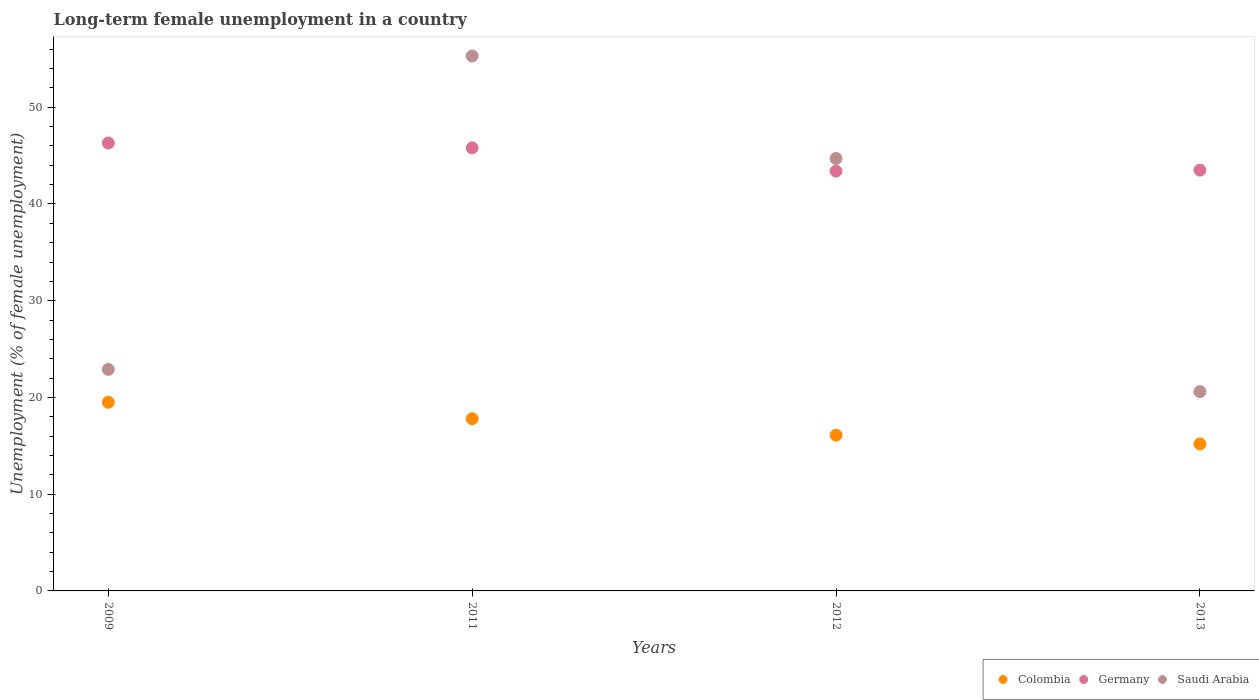How many different coloured dotlines are there?
Offer a very short reply. 3. What is the percentage of long-term unemployed female population in Colombia in 2009?
Offer a very short reply. 19.5. Across all years, what is the minimum percentage of long-term unemployed female population in Colombia?
Ensure brevity in your answer.  15.2. In which year was the percentage of long-term unemployed female population in Colombia minimum?
Provide a short and direct response. 2013. What is the total percentage of long-term unemployed female population in Colombia in the graph?
Give a very brief answer. 68.6. What is the difference between the percentage of long-term unemployed female population in Colombia in 2011 and that in 2013?
Your response must be concise. 2.6. What is the difference between the percentage of long-term unemployed female population in Germany in 2011 and the percentage of long-term unemployed female population in Saudi Arabia in 2013?
Your response must be concise. 25.2. What is the average percentage of long-term unemployed female population in Saudi Arabia per year?
Offer a very short reply. 35.88. In the year 2009, what is the difference between the percentage of long-term unemployed female population in Colombia and percentage of long-term unemployed female population in Germany?
Provide a succinct answer. -26.8. In how many years, is the percentage of long-term unemployed female population in Saudi Arabia greater than 40 %?
Provide a short and direct response. 2. What is the ratio of the percentage of long-term unemployed female population in Colombia in 2009 to that in 2013?
Ensure brevity in your answer.  1.28. Is the percentage of long-term unemployed female population in Germany in 2011 less than that in 2013?
Offer a very short reply. No. Is the difference between the percentage of long-term unemployed female population in Colombia in 2009 and 2012 greater than the difference between the percentage of long-term unemployed female population in Germany in 2009 and 2012?
Provide a short and direct response. Yes. What is the difference between the highest and the second highest percentage of long-term unemployed female population in Colombia?
Offer a terse response. 1.7. What is the difference between the highest and the lowest percentage of long-term unemployed female population in Colombia?
Keep it short and to the point. 4.3. Is the sum of the percentage of long-term unemployed female population in Germany in 2009 and 2011 greater than the maximum percentage of long-term unemployed female population in Saudi Arabia across all years?
Ensure brevity in your answer.  Yes. Are the values on the major ticks of Y-axis written in scientific E-notation?
Offer a terse response. No. Does the graph contain any zero values?
Make the answer very short. No. How many legend labels are there?
Your answer should be very brief. 3. What is the title of the graph?
Offer a terse response. Long-term female unemployment in a country. What is the label or title of the X-axis?
Your answer should be compact. Years. What is the label or title of the Y-axis?
Offer a very short reply. Unemployment (% of female unemployment). What is the Unemployment (% of female unemployment) of Colombia in 2009?
Make the answer very short. 19.5. What is the Unemployment (% of female unemployment) in Germany in 2009?
Your answer should be compact. 46.3. What is the Unemployment (% of female unemployment) of Saudi Arabia in 2009?
Provide a succinct answer. 22.9. What is the Unemployment (% of female unemployment) of Colombia in 2011?
Offer a very short reply. 17.8. What is the Unemployment (% of female unemployment) in Germany in 2011?
Your answer should be very brief. 45.8. What is the Unemployment (% of female unemployment) of Saudi Arabia in 2011?
Offer a terse response. 55.3. What is the Unemployment (% of female unemployment) of Colombia in 2012?
Offer a terse response. 16.1. What is the Unemployment (% of female unemployment) of Germany in 2012?
Ensure brevity in your answer.  43.4. What is the Unemployment (% of female unemployment) of Saudi Arabia in 2012?
Ensure brevity in your answer.  44.7. What is the Unemployment (% of female unemployment) in Colombia in 2013?
Offer a terse response. 15.2. What is the Unemployment (% of female unemployment) in Germany in 2013?
Your answer should be compact. 43.5. What is the Unemployment (% of female unemployment) in Saudi Arabia in 2013?
Give a very brief answer. 20.6. Across all years, what is the maximum Unemployment (% of female unemployment) in Colombia?
Your answer should be compact. 19.5. Across all years, what is the maximum Unemployment (% of female unemployment) of Germany?
Offer a very short reply. 46.3. Across all years, what is the maximum Unemployment (% of female unemployment) in Saudi Arabia?
Offer a terse response. 55.3. Across all years, what is the minimum Unemployment (% of female unemployment) in Colombia?
Offer a terse response. 15.2. Across all years, what is the minimum Unemployment (% of female unemployment) of Germany?
Keep it short and to the point. 43.4. Across all years, what is the minimum Unemployment (% of female unemployment) of Saudi Arabia?
Ensure brevity in your answer.  20.6. What is the total Unemployment (% of female unemployment) of Colombia in the graph?
Ensure brevity in your answer.  68.6. What is the total Unemployment (% of female unemployment) in Germany in the graph?
Your response must be concise. 179. What is the total Unemployment (% of female unemployment) in Saudi Arabia in the graph?
Your response must be concise. 143.5. What is the difference between the Unemployment (% of female unemployment) of Colombia in 2009 and that in 2011?
Give a very brief answer. 1.7. What is the difference between the Unemployment (% of female unemployment) of Saudi Arabia in 2009 and that in 2011?
Your answer should be very brief. -32.4. What is the difference between the Unemployment (% of female unemployment) of Germany in 2009 and that in 2012?
Provide a succinct answer. 2.9. What is the difference between the Unemployment (% of female unemployment) in Saudi Arabia in 2009 and that in 2012?
Provide a short and direct response. -21.8. What is the difference between the Unemployment (% of female unemployment) in Colombia in 2009 and that in 2013?
Keep it short and to the point. 4.3. What is the difference between the Unemployment (% of female unemployment) in Saudi Arabia in 2009 and that in 2013?
Provide a short and direct response. 2.3. What is the difference between the Unemployment (% of female unemployment) in Colombia in 2011 and that in 2012?
Ensure brevity in your answer.  1.7. What is the difference between the Unemployment (% of female unemployment) of Saudi Arabia in 2011 and that in 2013?
Keep it short and to the point. 34.7. What is the difference between the Unemployment (% of female unemployment) of Colombia in 2012 and that in 2013?
Your answer should be very brief. 0.9. What is the difference between the Unemployment (% of female unemployment) of Germany in 2012 and that in 2013?
Ensure brevity in your answer.  -0.1. What is the difference between the Unemployment (% of female unemployment) of Saudi Arabia in 2012 and that in 2013?
Give a very brief answer. 24.1. What is the difference between the Unemployment (% of female unemployment) in Colombia in 2009 and the Unemployment (% of female unemployment) in Germany in 2011?
Your response must be concise. -26.3. What is the difference between the Unemployment (% of female unemployment) of Colombia in 2009 and the Unemployment (% of female unemployment) of Saudi Arabia in 2011?
Make the answer very short. -35.8. What is the difference between the Unemployment (% of female unemployment) of Colombia in 2009 and the Unemployment (% of female unemployment) of Germany in 2012?
Your answer should be very brief. -23.9. What is the difference between the Unemployment (% of female unemployment) in Colombia in 2009 and the Unemployment (% of female unemployment) in Saudi Arabia in 2012?
Give a very brief answer. -25.2. What is the difference between the Unemployment (% of female unemployment) of Germany in 2009 and the Unemployment (% of female unemployment) of Saudi Arabia in 2012?
Your response must be concise. 1.6. What is the difference between the Unemployment (% of female unemployment) in Germany in 2009 and the Unemployment (% of female unemployment) in Saudi Arabia in 2013?
Ensure brevity in your answer.  25.7. What is the difference between the Unemployment (% of female unemployment) of Colombia in 2011 and the Unemployment (% of female unemployment) of Germany in 2012?
Offer a terse response. -25.6. What is the difference between the Unemployment (% of female unemployment) in Colombia in 2011 and the Unemployment (% of female unemployment) in Saudi Arabia in 2012?
Your answer should be compact. -26.9. What is the difference between the Unemployment (% of female unemployment) of Germany in 2011 and the Unemployment (% of female unemployment) of Saudi Arabia in 2012?
Offer a very short reply. 1.1. What is the difference between the Unemployment (% of female unemployment) in Colombia in 2011 and the Unemployment (% of female unemployment) in Germany in 2013?
Keep it short and to the point. -25.7. What is the difference between the Unemployment (% of female unemployment) in Colombia in 2011 and the Unemployment (% of female unemployment) in Saudi Arabia in 2013?
Give a very brief answer. -2.8. What is the difference between the Unemployment (% of female unemployment) in Germany in 2011 and the Unemployment (% of female unemployment) in Saudi Arabia in 2013?
Your answer should be very brief. 25.2. What is the difference between the Unemployment (% of female unemployment) of Colombia in 2012 and the Unemployment (% of female unemployment) of Germany in 2013?
Your answer should be compact. -27.4. What is the difference between the Unemployment (% of female unemployment) of Germany in 2012 and the Unemployment (% of female unemployment) of Saudi Arabia in 2013?
Keep it short and to the point. 22.8. What is the average Unemployment (% of female unemployment) in Colombia per year?
Your response must be concise. 17.15. What is the average Unemployment (% of female unemployment) of Germany per year?
Offer a terse response. 44.75. What is the average Unemployment (% of female unemployment) in Saudi Arabia per year?
Offer a terse response. 35.88. In the year 2009, what is the difference between the Unemployment (% of female unemployment) of Colombia and Unemployment (% of female unemployment) of Germany?
Provide a short and direct response. -26.8. In the year 2009, what is the difference between the Unemployment (% of female unemployment) of Colombia and Unemployment (% of female unemployment) of Saudi Arabia?
Provide a short and direct response. -3.4. In the year 2009, what is the difference between the Unemployment (% of female unemployment) in Germany and Unemployment (% of female unemployment) in Saudi Arabia?
Offer a very short reply. 23.4. In the year 2011, what is the difference between the Unemployment (% of female unemployment) in Colombia and Unemployment (% of female unemployment) in Saudi Arabia?
Make the answer very short. -37.5. In the year 2012, what is the difference between the Unemployment (% of female unemployment) in Colombia and Unemployment (% of female unemployment) in Germany?
Your answer should be very brief. -27.3. In the year 2012, what is the difference between the Unemployment (% of female unemployment) of Colombia and Unemployment (% of female unemployment) of Saudi Arabia?
Provide a succinct answer. -28.6. In the year 2012, what is the difference between the Unemployment (% of female unemployment) in Germany and Unemployment (% of female unemployment) in Saudi Arabia?
Give a very brief answer. -1.3. In the year 2013, what is the difference between the Unemployment (% of female unemployment) in Colombia and Unemployment (% of female unemployment) in Germany?
Keep it short and to the point. -28.3. In the year 2013, what is the difference between the Unemployment (% of female unemployment) of Colombia and Unemployment (% of female unemployment) of Saudi Arabia?
Keep it short and to the point. -5.4. In the year 2013, what is the difference between the Unemployment (% of female unemployment) in Germany and Unemployment (% of female unemployment) in Saudi Arabia?
Your answer should be very brief. 22.9. What is the ratio of the Unemployment (% of female unemployment) of Colombia in 2009 to that in 2011?
Make the answer very short. 1.1. What is the ratio of the Unemployment (% of female unemployment) in Germany in 2009 to that in 2011?
Offer a terse response. 1.01. What is the ratio of the Unemployment (% of female unemployment) of Saudi Arabia in 2009 to that in 2011?
Provide a short and direct response. 0.41. What is the ratio of the Unemployment (% of female unemployment) of Colombia in 2009 to that in 2012?
Keep it short and to the point. 1.21. What is the ratio of the Unemployment (% of female unemployment) in Germany in 2009 to that in 2012?
Ensure brevity in your answer.  1.07. What is the ratio of the Unemployment (% of female unemployment) in Saudi Arabia in 2009 to that in 2012?
Your answer should be compact. 0.51. What is the ratio of the Unemployment (% of female unemployment) in Colombia in 2009 to that in 2013?
Provide a short and direct response. 1.28. What is the ratio of the Unemployment (% of female unemployment) of Germany in 2009 to that in 2013?
Make the answer very short. 1.06. What is the ratio of the Unemployment (% of female unemployment) in Saudi Arabia in 2009 to that in 2013?
Offer a very short reply. 1.11. What is the ratio of the Unemployment (% of female unemployment) in Colombia in 2011 to that in 2012?
Offer a very short reply. 1.11. What is the ratio of the Unemployment (% of female unemployment) in Germany in 2011 to that in 2012?
Your answer should be compact. 1.06. What is the ratio of the Unemployment (% of female unemployment) in Saudi Arabia in 2011 to that in 2012?
Your answer should be compact. 1.24. What is the ratio of the Unemployment (% of female unemployment) in Colombia in 2011 to that in 2013?
Keep it short and to the point. 1.17. What is the ratio of the Unemployment (% of female unemployment) of Germany in 2011 to that in 2013?
Offer a very short reply. 1.05. What is the ratio of the Unemployment (% of female unemployment) in Saudi Arabia in 2011 to that in 2013?
Offer a terse response. 2.68. What is the ratio of the Unemployment (% of female unemployment) in Colombia in 2012 to that in 2013?
Give a very brief answer. 1.06. What is the ratio of the Unemployment (% of female unemployment) in Saudi Arabia in 2012 to that in 2013?
Give a very brief answer. 2.17. What is the difference between the highest and the second highest Unemployment (% of female unemployment) of Germany?
Keep it short and to the point. 0.5. What is the difference between the highest and the second highest Unemployment (% of female unemployment) in Saudi Arabia?
Ensure brevity in your answer.  10.6. What is the difference between the highest and the lowest Unemployment (% of female unemployment) in Saudi Arabia?
Make the answer very short. 34.7. 